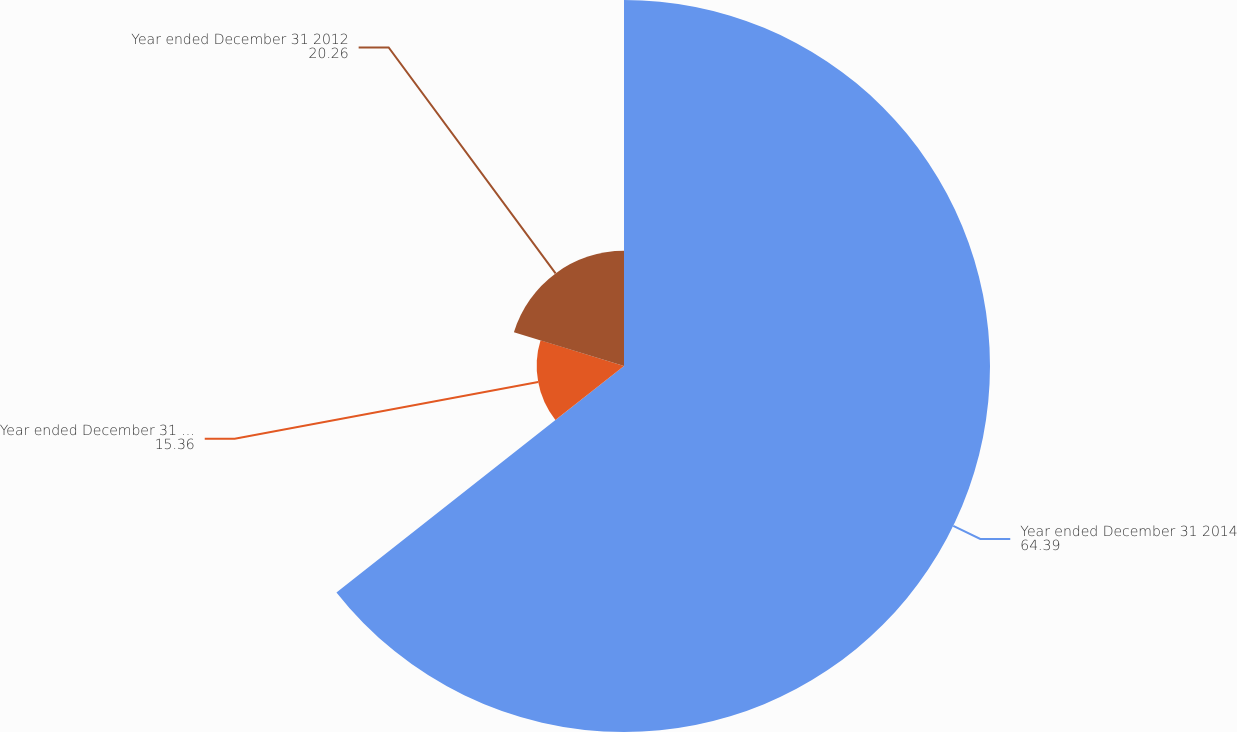Convert chart to OTSL. <chart><loc_0><loc_0><loc_500><loc_500><pie_chart><fcel>Year ended December 31 2014<fcel>Year ended December 31 2013<fcel>Year ended December 31 2012<nl><fcel>64.39%<fcel>15.36%<fcel>20.26%<nl></chart> 